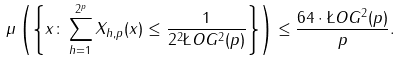<formula> <loc_0><loc_0><loc_500><loc_500>\mu \left ( \left \{ x \colon \sum _ { h = 1 } ^ { 2 ^ { p } } X _ { h , p } ( x ) \leq \frac { 1 } { 2 ^ { 2 } \L O G ^ { 2 } ( p ) } \right \} \right ) \leq \frac { 6 4 \cdot \L O G ^ { 2 } ( p ) } { p } .</formula> 